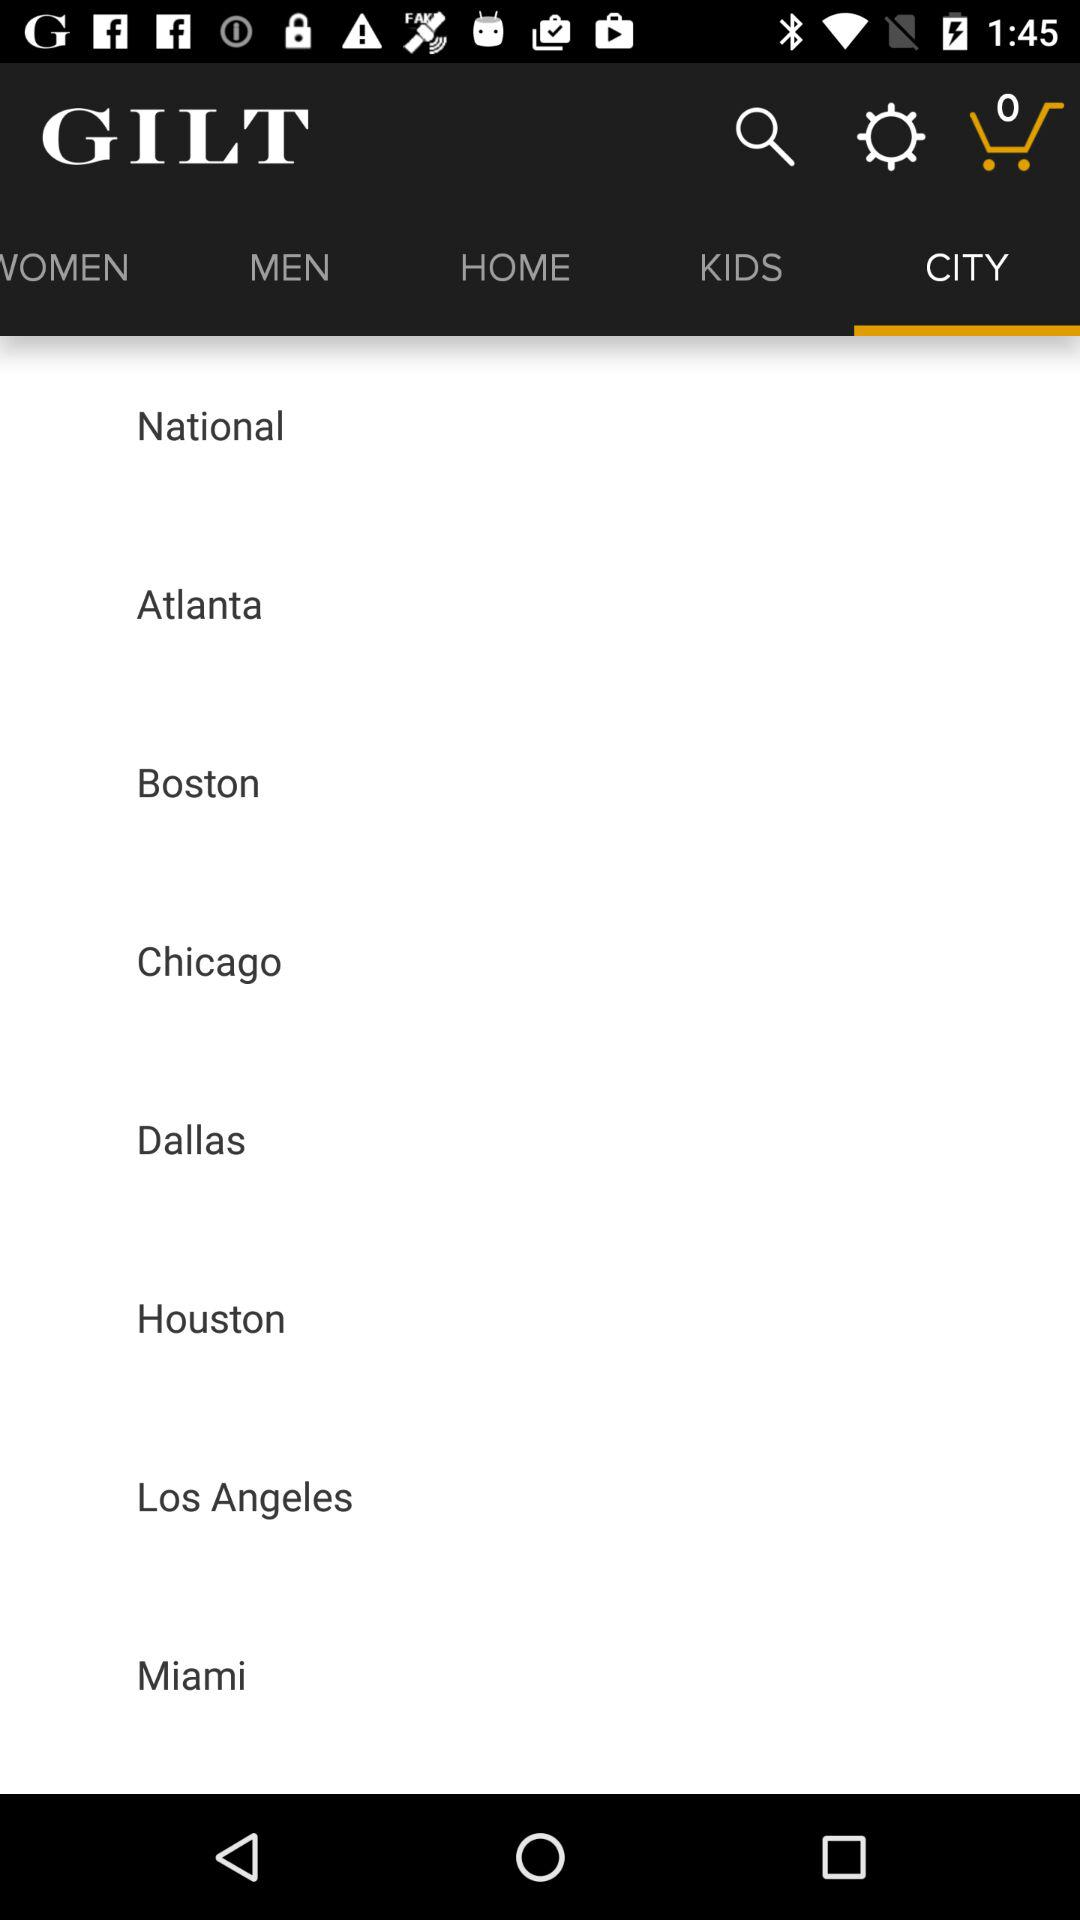Which city is selected?
When the provided information is insufficient, respond with <no answer>. <no answer> 